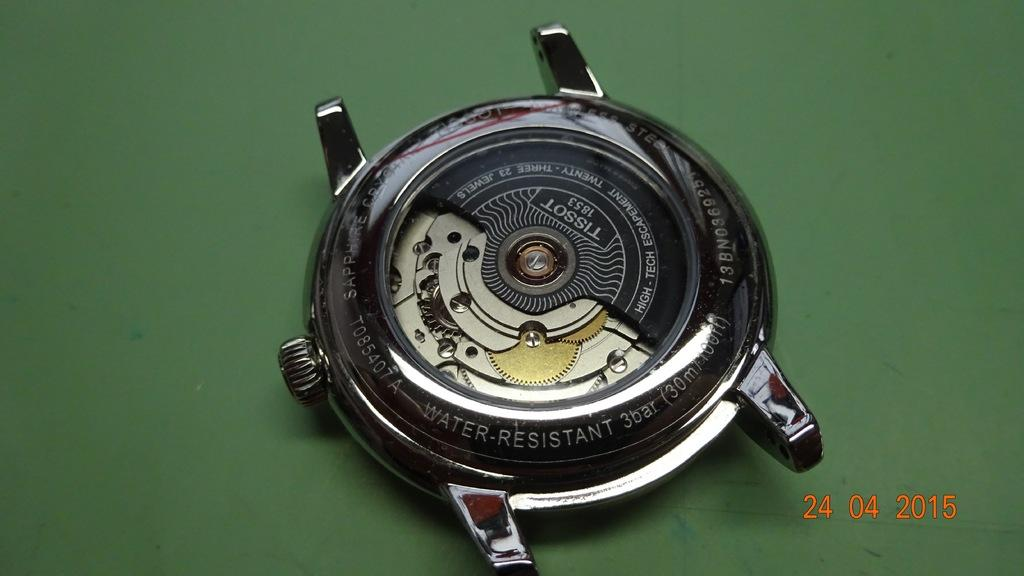<image>
Give a short and clear explanation of the subsequent image. The back of a Tissot wrist watch is laying open, on a green surface, in a photo taken on April 24, 2015. 